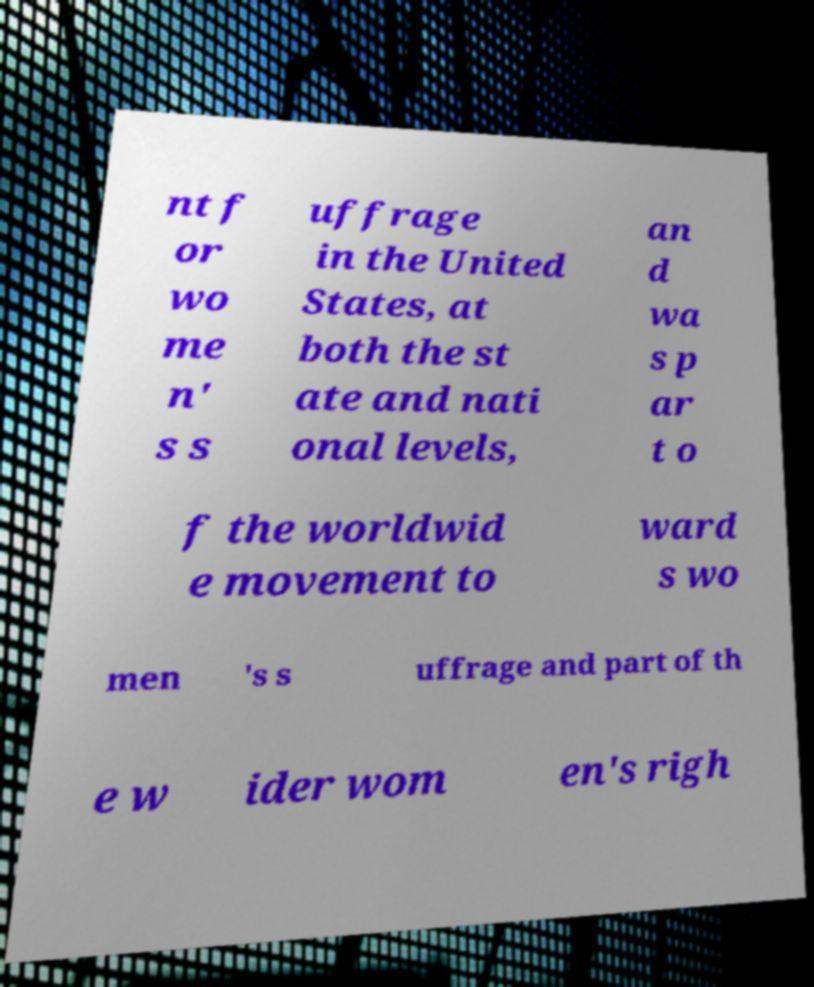Please identify and transcribe the text found in this image. nt f or wo me n' s s uffrage in the United States, at both the st ate and nati onal levels, an d wa s p ar t o f the worldwid e movement to ward s wo men 's s uffrage and part of th e w ider wom en's righ 